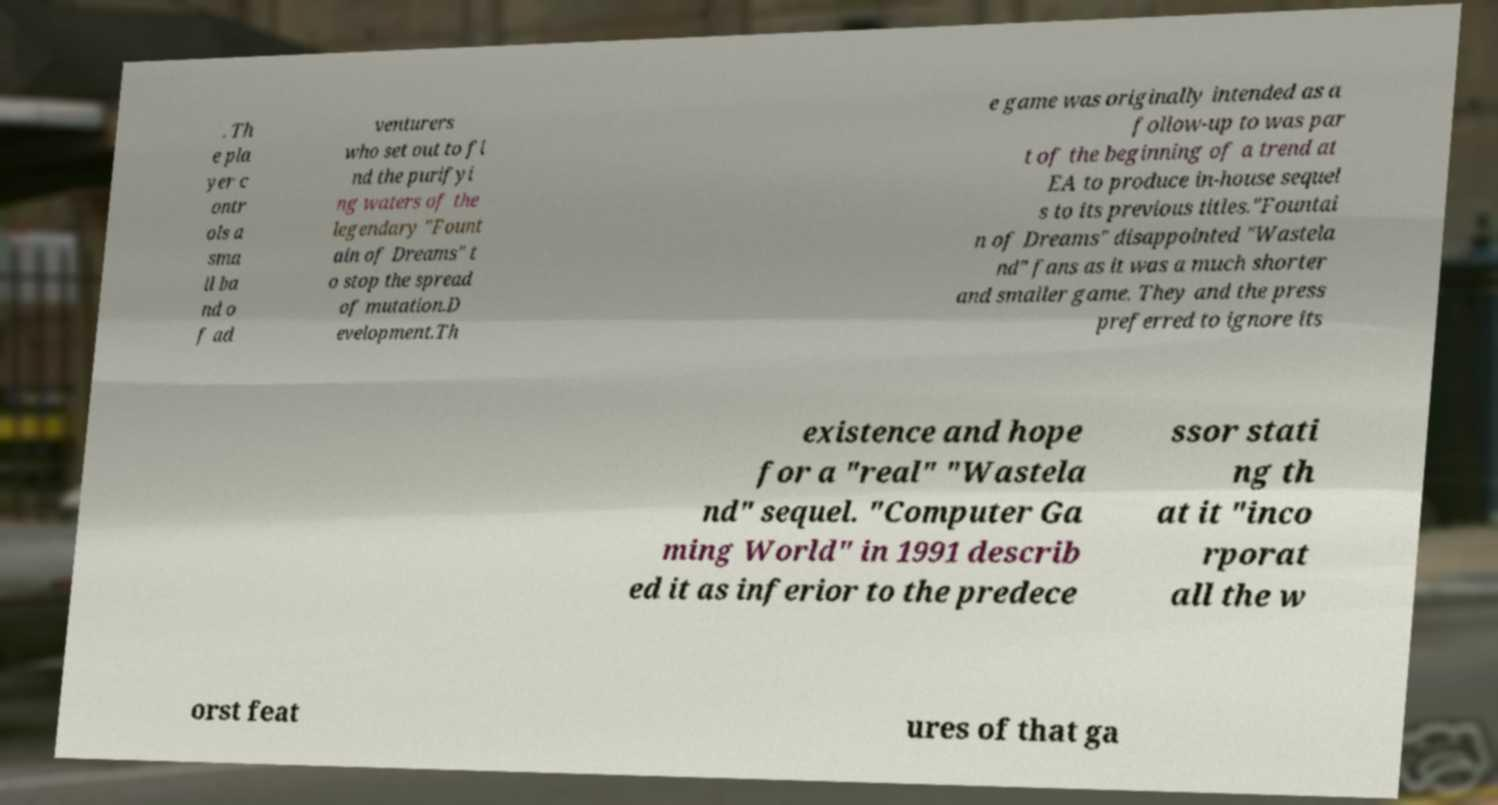There's text embedded in this image that I need extracted. Can you transcribe it verbatim? . Th e pla yer c ontr ols a sma ll ba nd o f ad venturers who set out to fi nd the purifyi ng waters of the legendary "Fount ain of Dreams" t o stop the spread of mutation.D evelopment.Th e game was originally intended as a follow-up to was par t of the beginning of a trend at EA to produce in-house sequel s to its previous titles."Fountai n of Dreams" disappointed "Wastela nd" fans as it was a much shorter and smaller game. They and the press preferred to ignore its existence and hope for a "real" "Wastela nd" sequel. "Computer Ga ming World" in 1991 describ ed it as inferior to the predece ssor stati ng th at it "inco rporat all the w orst feat ures of that ga 